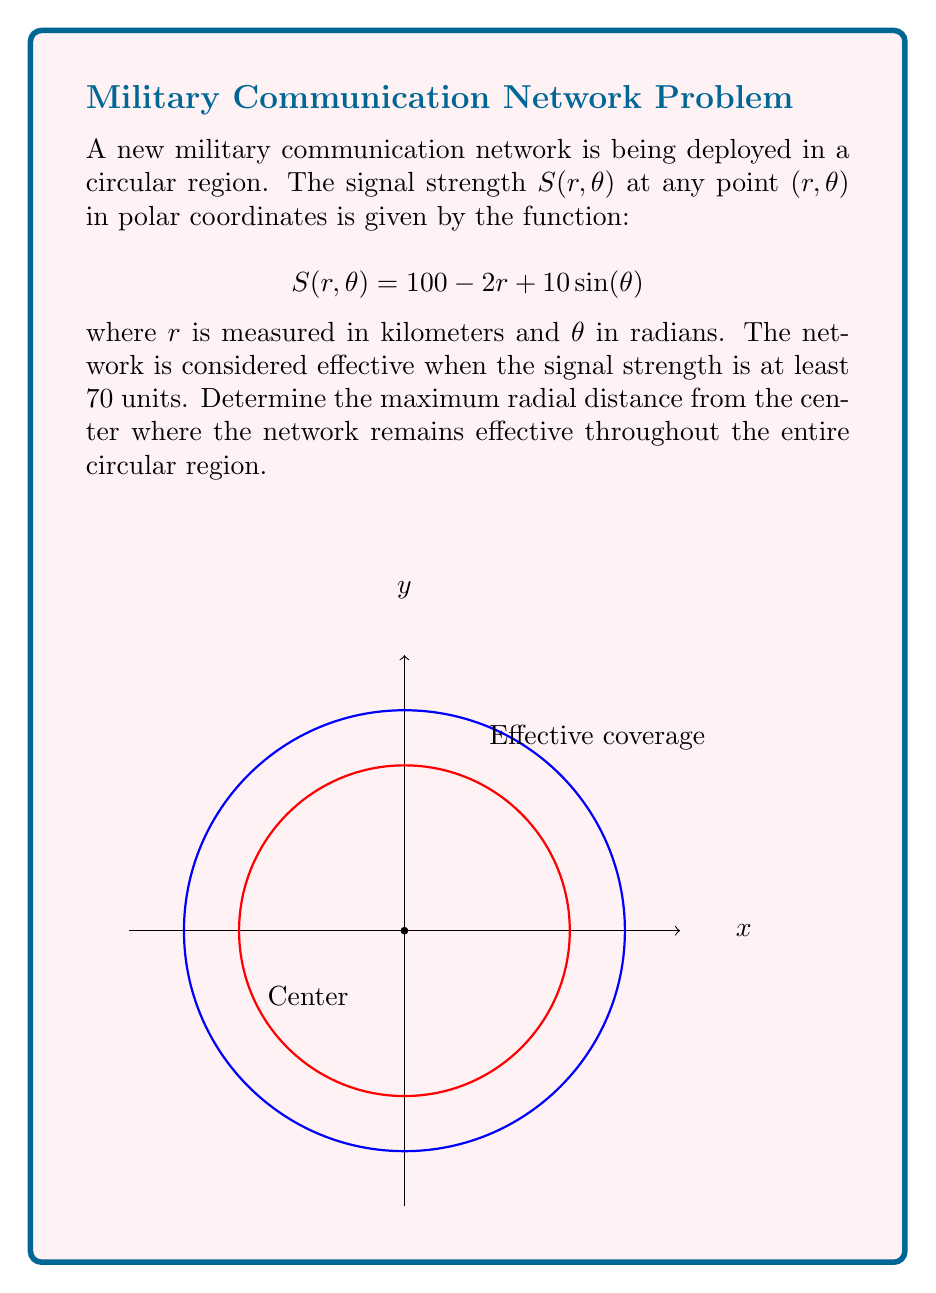Teach me how to tackle this problem. Let's approach this step-by-step:

1) The network is effective when $S(r,\theta) \geq 70$. We need to find the maximum $r$ that satisfies this condition for all $\theta$.

2) Substitute the condition into the given function:

   $$70 \leq 100 - 2r + 10\sin(\theta)$$

3) Rearrange the inequality:

   $$2r \leq 30 + 10\sin(\theta)$$
   $$r \leq 15 + 5\sin(\theta)$$

4) The right-hand side of this inequality varies with $\theta$. To ensure the network is effective throughout the entire region, we need to consider the minimum value of $15 + 5\sin(\theta)$.

5) The minimum value of $\sin(\theta)$ is -1, which occurs when $\theta = 3\pi/2$.

6) Therefore, the minimum value of the right-hand side is:

   $$15 + 5\sin(3\pi/2) = 15 + 5(-1) = 10$$

7) Thus, for the network to be effective throughout the entire circular region:

   $$r \leq 10$$

This means the maximum radial distance where the network remains effective throughout the entire circular region is 10 kilometers.
Answer: 10 kilometers 